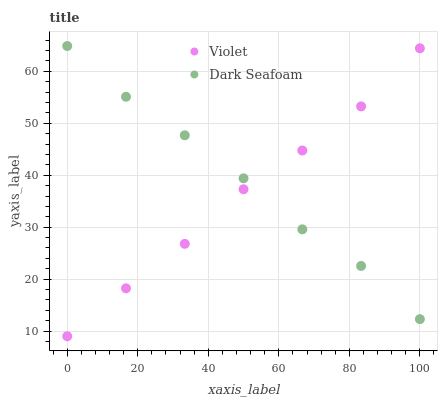Does Violet have the minimum area under the curve?
Answer yes or no. Yes. Does Dark Seafoam have the maximum area under the curve?
Answer yes or no. Yes. Does Violet have the maximum area under the curve?
Answer yes or no. No. Is Violet the smoothest?
Answer yes or no. Yes. Is Dark Seafoam the roughest?
Answer yes or no. Yes. Is Violet the roughest?
Answer yes or no. No. Does Violet have the lowest value?
Answer yes or no. Yes. Does Dark Seafoam have the highest value?
Answer yes or no. Yes. Does Violet have the highest value?
Answer yes or no. No. Does Dark Seafoam intersect Violet?
Answer yes or no. Yes. Is Dark Seafoam less than Violet?
Answer yes or no. No. Is Dark Seafoam greater than Violet?
Answer yes or no. No. 